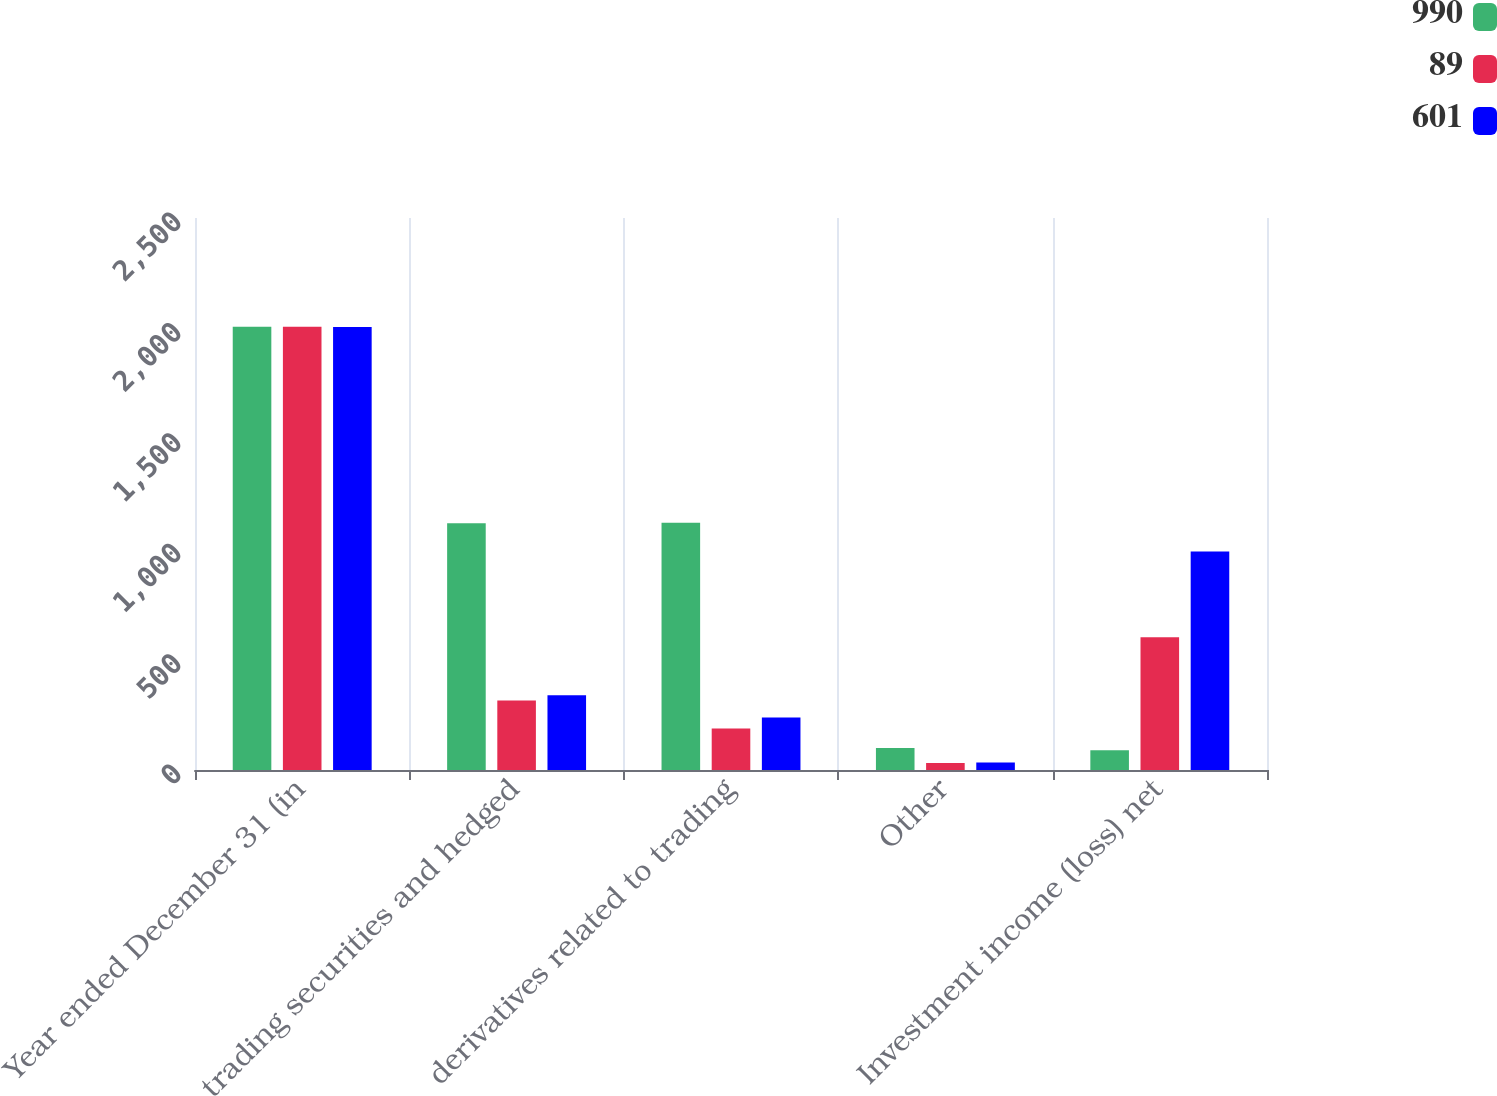<chart> <loc_0><loc_0><loc_500><loc_500><stacked_bar_chart><ecel><fcel>Year ended December 31 (in<fcel>trading securities and hedged<fcel>derivatives related to trading<fcel>Other<fcel>Investment income (loss) net<nl><fcel>990<fcel>2008<fcel>1117<fcel>1120<fcel>100<fcel>89<nl><fcel>89<fcel>2007<fcel>315<fcel>188<fcel>32<fcel>601<nl><fcel>601<fcel>2006<fcel>339<fcel>238<fcel>34<fcel>990<nl></chart> 